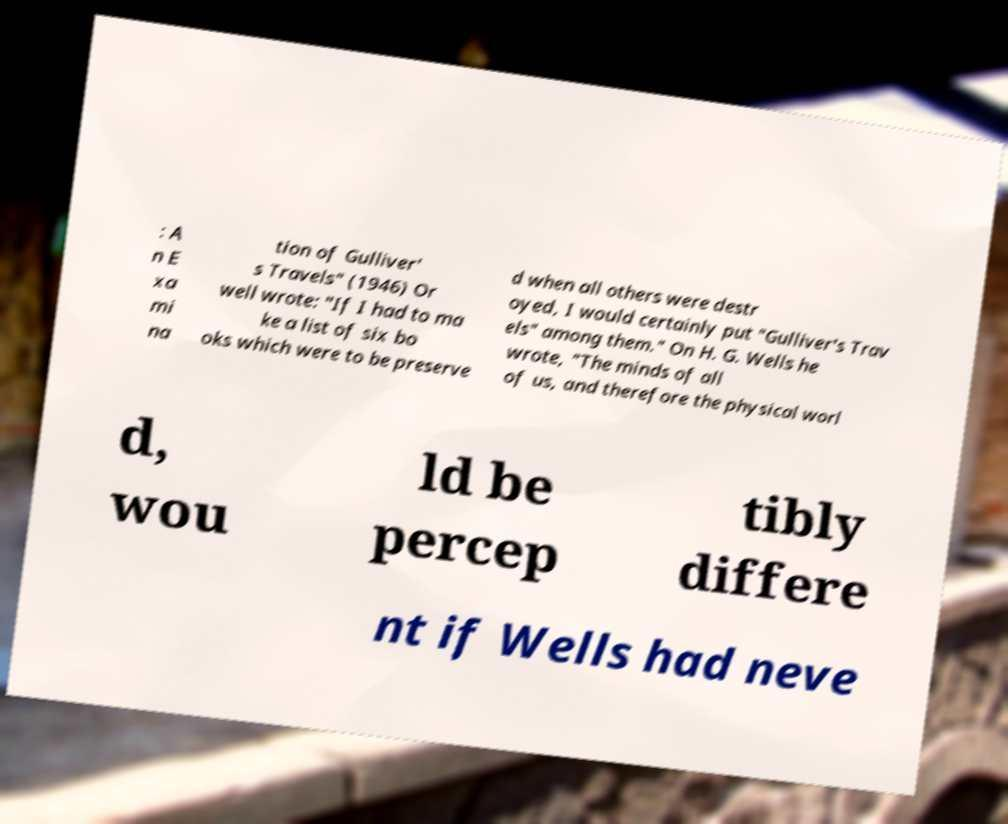Could you assist in decoding the text presented in this image and type it out clearly? : A n E xa mi na tion of Gulliver' s Travels" (1946) Or well wrote: "If I had to ma ke a list of six bo oks which were to be preserve d when all others were destr oyed, I would certainly put "Gulliver's Trav els" among them." On H. G. Wells he wrote, "The minds of all of us, and therefore the physical worl d, wou ld be percep tibly differe nt if Wells had neve 